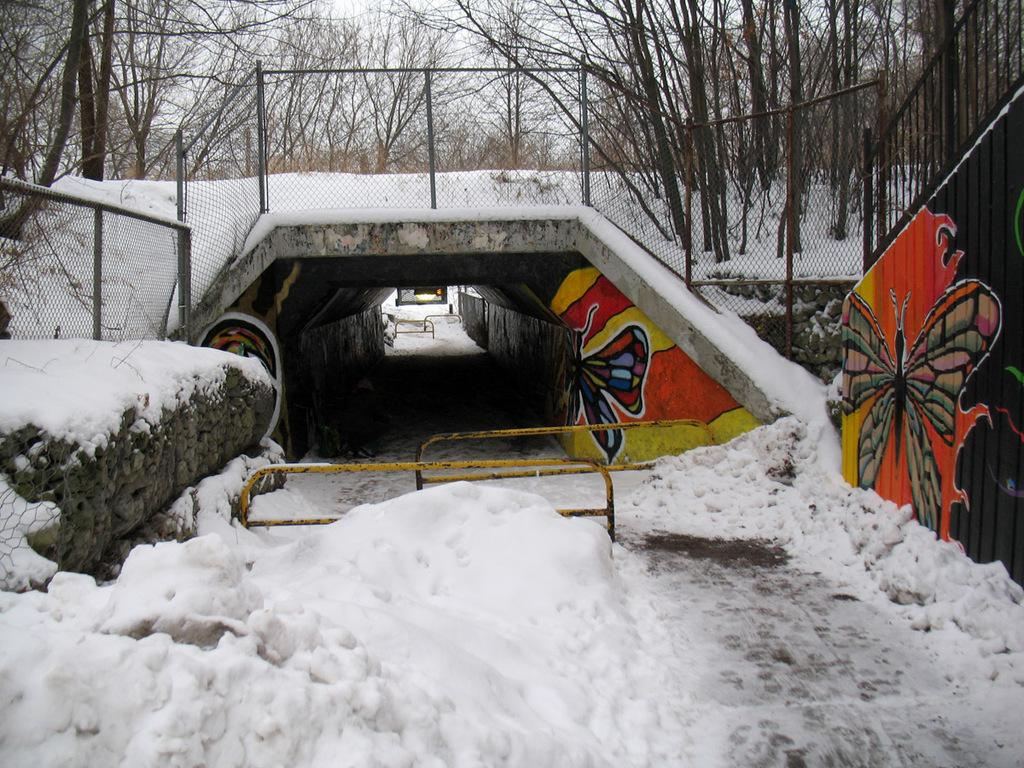What type of weather is depicted in the image? There is snow at the bottom of the image, indicating a winter scene. What can be seen on the right side of the image? There is a railing on the right side of the image. What structures are visible in the background of the image? There is a bridge and a net in the background of the image. What type of vegetation is visible in the background of the image? Trees are visible in the background of the image. Can the mother be seen running in the image? There is no mother or running depicted in the image; it features a snowy scene with a railing, bridge, net, and trees. 